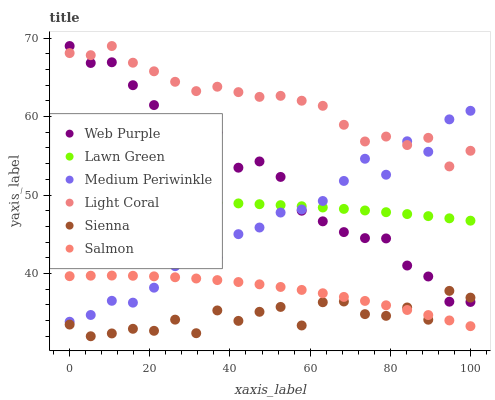Does Sienna have the minimum area under the curve?
Answer yes or no. Yes. Does Light Coral have the maximum area under the curve?
Answer yes or no. Yes. Does Medium Periwinkle have the minimum area under the curve?
Answer yes or no. No. Does Medium Periwinkle have the maximum area under the curve?
Answer yes or no. No. Is Lawn Green the smoothest?
Answer yes or no. Yes. Is Sienna the roughest?
Answer yes or no. Yes. Is Medium Periwinkle the smoothest?
Answer yes or no. No. Is Medium Periwinkle the roughest?
Answer yes or no. No. Does Sienna have the lowest value?
Answer yes or no. Yes. Does Medium Periwinkle have the lowest value?
Answer yes or no. No. Does Web Purple have the highest value?
Answer yes or no. Yes. Does Medium Periwinkle have the highest value?
Answer yes or no. No. Is Salmon less than Lawn Green?
Answer yes or no. Yes. Is Light Coral greater than Lawn Green?
Answer yes or no. Yes. Does Medium Periwinkle intersect Light Coral?
Answer yes or no. Yes. Is Medium Periwinkle less than Light Coral?
Answer yes or no. No. Is Medium Periwinkle greater than Light Coral?
Answer yes or no. No. Does Salmon intersect Lawn Green?
Answer yes or no. No. 